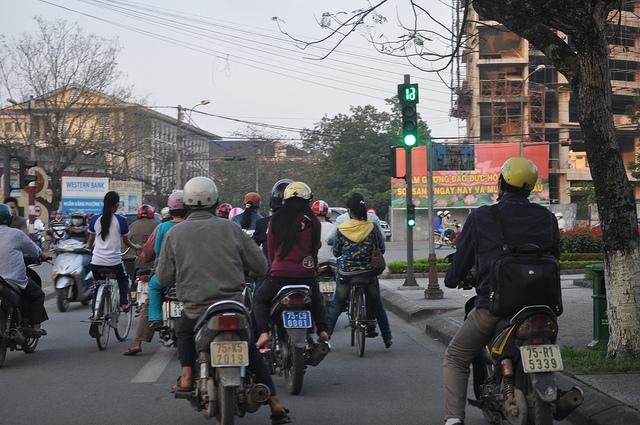What color are the numbers on the top of the pole with the traffic lights?

Choices:
A) red
B) yellow
C) green
D) blue green 